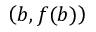Convert formula to latex. <formula><loc_0><loc_0><loc_500><loc_500>\left ( b , f ( b ) \right )</formula> 